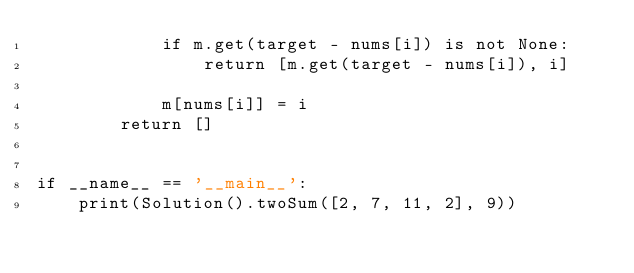Convert code to text. <code><loc_0><loc_0><loc_500><loc_500><_Python_>            if m.get(target - nums[i]) is not None:
                return [m.get(target - nums[i]), i]

            m[nums[i]] = i
        return []


if __name__ == '__main__':
    print(Solution().twoSum([2, 7, 11, 2], 9))
</code> 